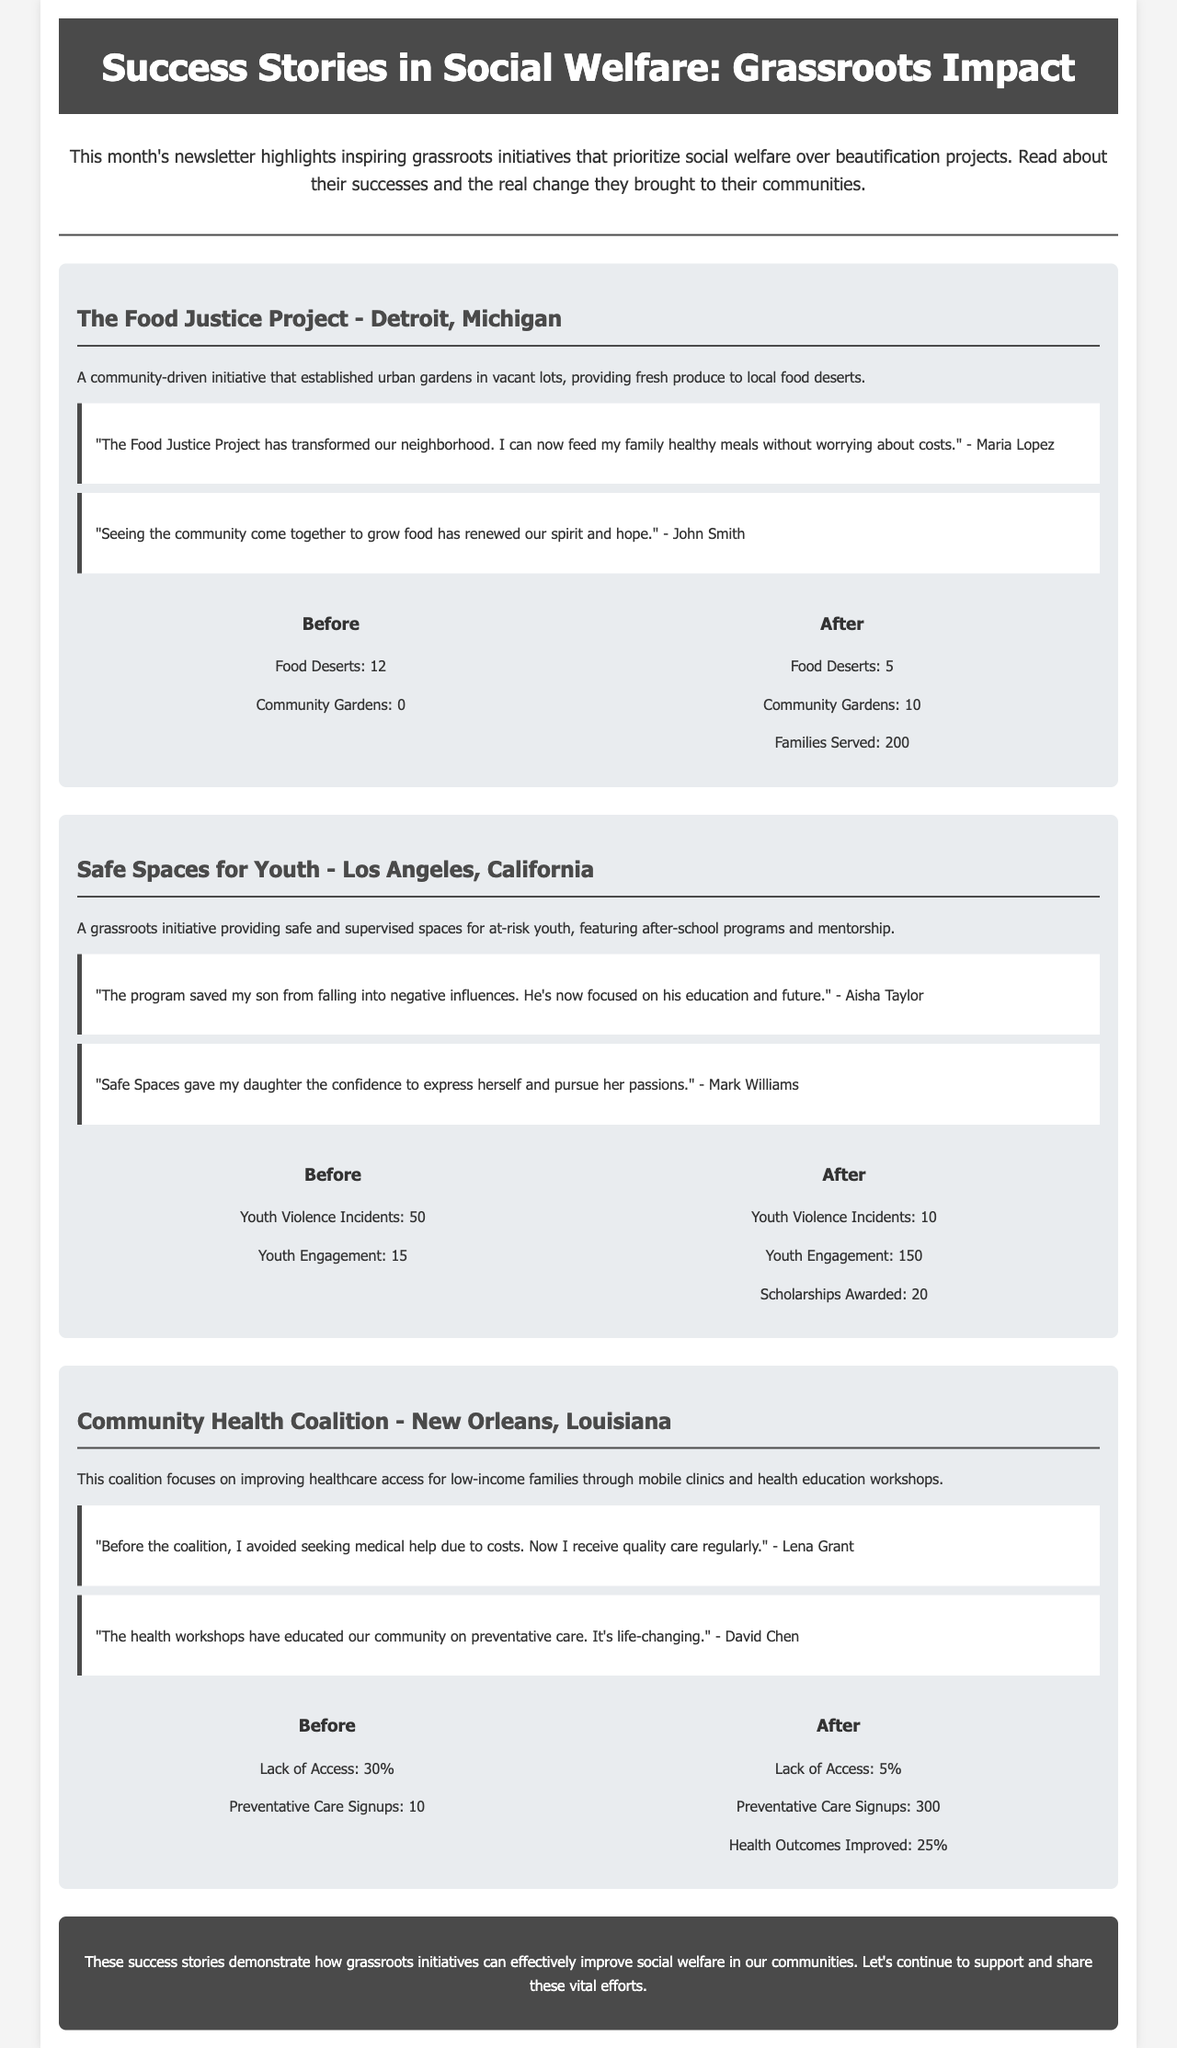What is the title of the newsletter? The title of the newsletter is stated in the header section, introducing the content focus on grassroots initiatives in social welfare.
Answer: Success Stories in Social Welfare: Grassroots Impact How many food deserts were there before the Food Justice Project? The number of food deserts before the initiative is provided as a specific data point in the Food Justice Project section.
Answer: 12 What percentage of lack of access to health care was reported before the Community Health Coalition? The lack of access percentage before the coalition is mentioned along with other data points in the Community Health Coalition section.
Answer: 30% What was the number of youth engagement before the Safe Spaces for Youth initiative? The number of youth engagement is a specific data point in the Safe Spaces for Youth section, indicating the situation prior to the initiative.
Answer: 15 How many community gardens were established after the Food Justice Project? The document provides a specific data point regarding the number of community gardens after the Food Justice Project, highlighting the impact made.
Answer: 10 Which city did the Community Health Coalition serve? The city is mentioned at the beginning of the Community Health Coalition section, identifying its focus on local community health needs.
Answer: New Orleans What impact did the Safe Spaces for Youth initiative have on youth violence incidents? The reduction in youth violence incidents is indicated in the data points in the Safe Spaces for Youth section, showing a significant decrease.
Answer: 10 What is the primary focus of this newsletter? The introductory paragraph explains the overall focus of the newsletter, which pertains to grassroots initiatives and community welfare.
Answer: Social welfare How many families were served after the Food Justice Project? The newsletter provides a specific number of families served in the data points section, showing the outreach success of the initiative.
Answer: 200 